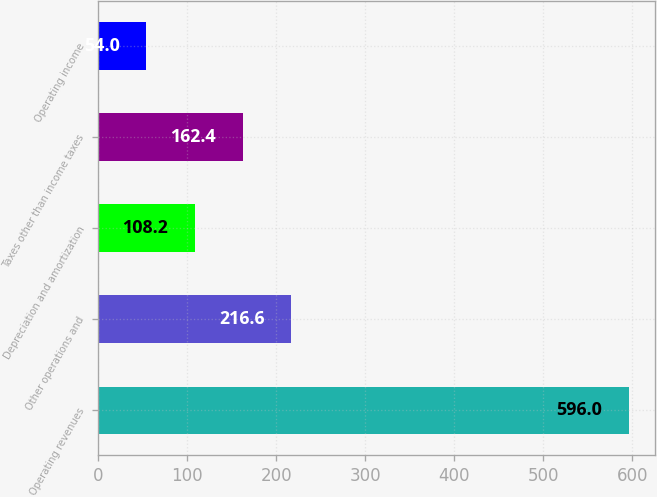Convert chart to OTSL. <chart><loc_0><loc_0><loc_500><loc_500><bar_chart><fcel>Operating revenues<fcel>Other operations and<fcel>Depreciation and amortization<fcel>Taxes other than income taxes<fcel>Operating income<nl><fcel>596<fcel>216.6<fcel>108.2<fcel>162.4<fcel>54<nl></chart> 